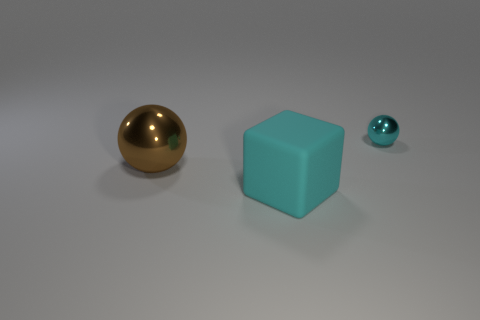Subtract 1 spheres. How many spheres are left? 1 Add 2 tiny blue matte balls. How many objects exist? 5 Subtract all blocks. How many objects are left? 2 Subtract all cyan spheres. How many spheres are left? 1 Add 2 large blue blocks. How many large blue blocks exist? 2 Subtract 1 brown spheres. How many objects are left? 2 Subtract all green balls. Subtract all green blocks. How many balls are left? 2 Subtract all blue cubes. How many cyan balls are left? 1 Subtract all brown metallic objects. Subtract all large things. How many objects are left? 0 Add 3 cyan matte cubes. How many cyan matte cubes are left? 4 